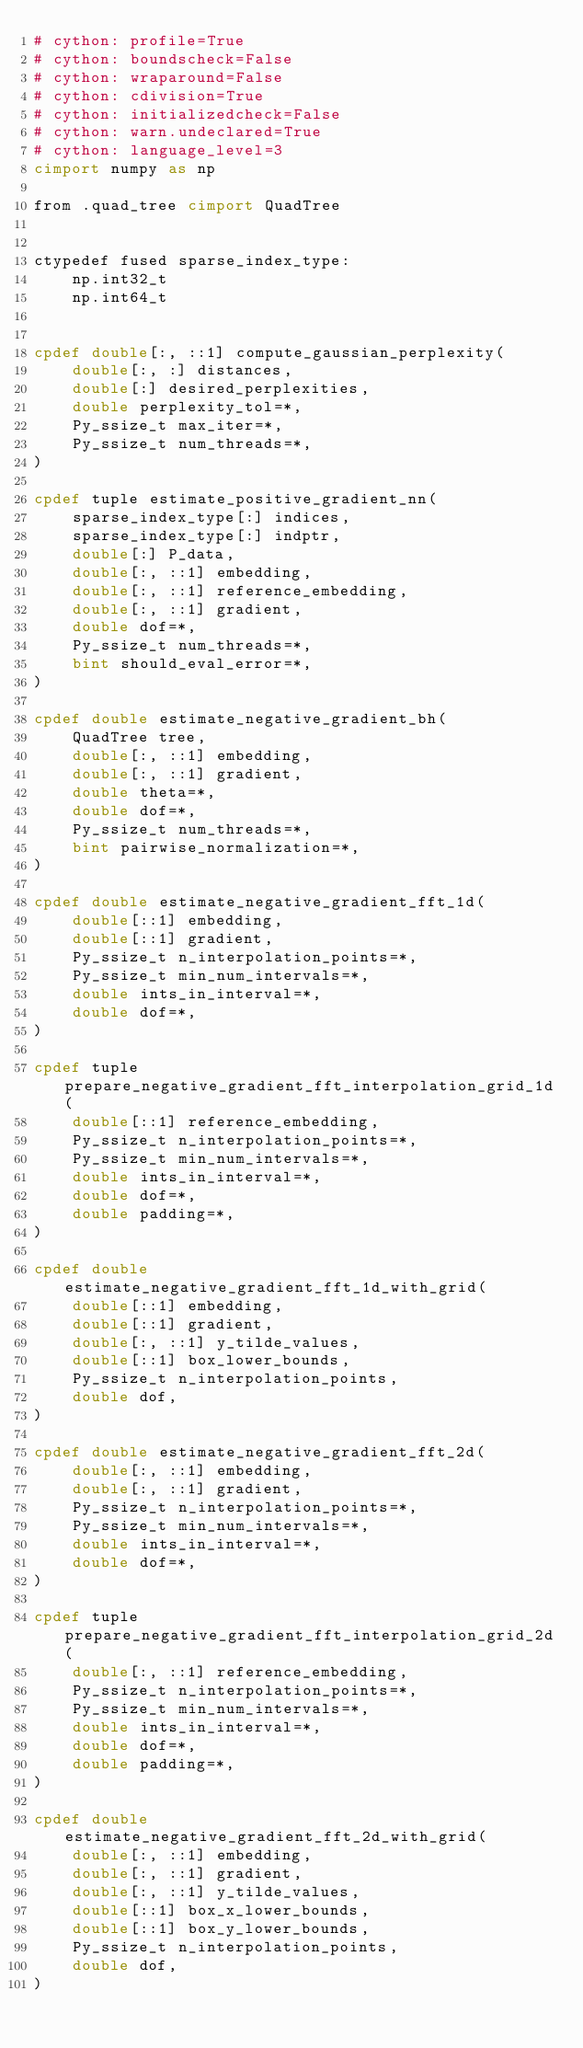Convert code to text. <code><loc_0><loc_0><loc_500><loc_500><_Cython_># cython: profile=True
# cython: boundscheck=False
# cython: wraparound=False
# cython: cdivision=True
# cython: initializedcheck=False
# cython: warn.undeclared=True
# cython: language_level=3
cimport numpy as np

from .quad_tree cimport QuadTree


ctypedef fused sparse_index_type:
    np.int32_t
    np.int64_t


cpdef double[:, ::1] compute_gaussian_perplexity(
    double[:, :] distances,
    double[:] desired_perplexities,
    double perplexity_tol=*,
    Py_ssize_t max_iter=*,
    Py_ssize_t num_threads=*,
)

cpdef tuple estimate_positive_gradient_nn(
    sparse_index_type[:] indices,
    sparse_index_type[:] indptr,
    double[:] P_data,
    double[:, ::1] embedding,
    double[:, ::1] reference_embedding,
    double[:, ::1] gradient,
    double dof=*,
    Py_ssize_t num_threads=*,
    bint should_eval_error=*,
)

cpdef double estimate_negative_gradient_bh(
    QuadTree tree,
    double[:, ::1] embedding,
    double[:, ::1] gradient,
    double theta=*,
    double dof=*,
    Py_ssize_t num_threads=*,
    bint pairwise_normalization=*,
)

cpdef double estimate_negative_gradient_fft_1d(
    double[::1] embedding,
    double[::1] gradient,
    Py_ssize_t n_interpolation_points=*,
    Py_ssize_t min_num_intervals=*,
    double ints_in_interval=*,
    double dof=*,
)

cpdef tuple prepare_negative_gradient_fft_interpolation_grid_1d(
    double[::1] reference_embedding,
    Py_ssize_t n_interpolation_points=*,
    Py_ssize_t min_num_intervals=*,
    double ints_in_interval=*,
    double dof=*,
    double padding=*,
)

cpdef double estimate_negative_gradient_fft_1d_with_grid(
    double[::1] embedding,
    double[::1] gradient,
    double[:, ::1] y_tilde_values,
    double[::1] box_lower_bounds,
    Py_ssize_t n_interpolation_points,
    double dof,
)

cpdef double estimate_negative_gradient_fft_2d(
    double[:, ::1] embedding,
    double[:, ::1] gradient,
    Py_ssize_t n_interpolation_points=*,
    Py_ssize_t min_num_intervals=*,
    double ints_in_interval=*,
    double dof=*,
)

cpdef tuple prepare_negative_gradient_fft_interpolation_grid_2d(
    double[:, ::1] reference_embedding,
    Py_ssize_t n_interpolation_points=*,
    Py_ssize_t min_num_intervals=*,
    double ints_in_interval=*,
    double dof=*,
    double padding=*,
)

cpdef double estimate_negative_gradient_fft_2d_with_grid(
    double[:, ::1] embedding,
    double[:, ::1] gradient,
    double[:, ::1] y_tilde_values,
    double[::1] box_x_lower_bounds,
    double[::1] box_y_lower_bounds,
    Py_ssize_t n_interpolation_points,
    double dof,
)
</code> 